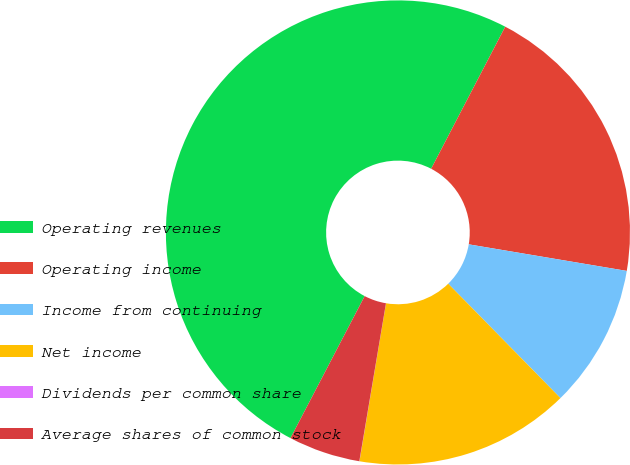Convert chart to OTSL. <chart><loc_0><loc_0><loc_500><loc_500><pie_chart><fcel>Operating revenues<fcel>Operating income<fcel>Income from continuing<fcel>Net income<fcel>Dividends per common share<fcel>Average shares of common stock<nl><fcel>49.99%<fcel>20.0%<fcel>10.0%<fcel>15.0%<fcel>0.01%<fcel>5.0%<nl></chart> 